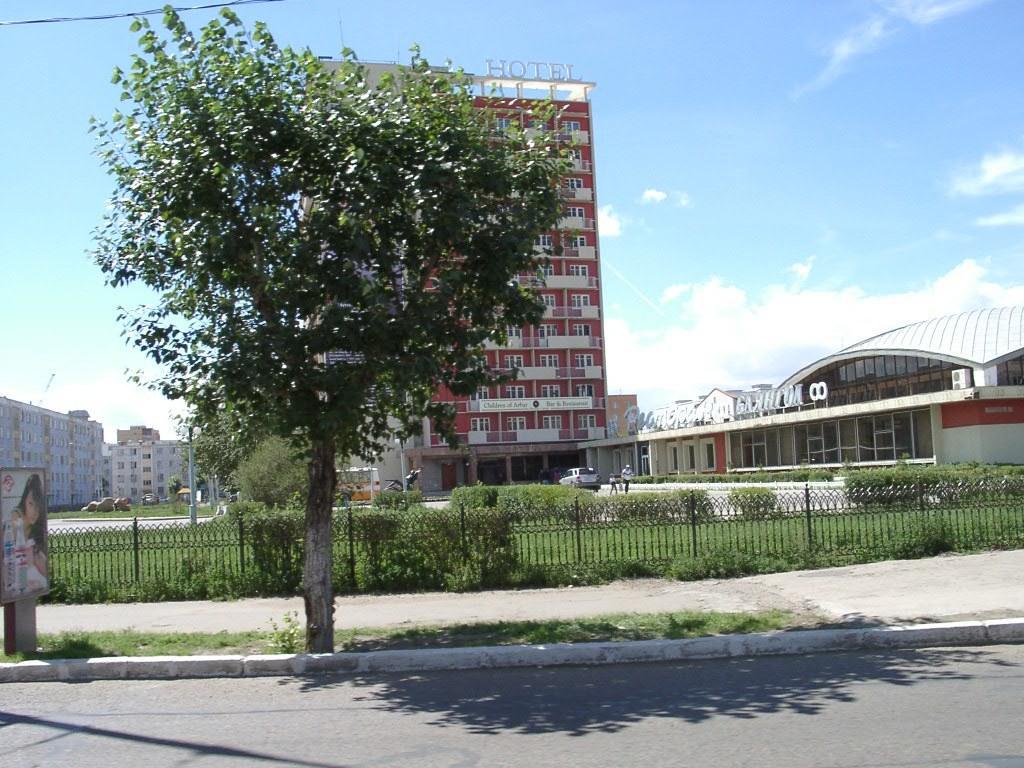Could you give a brief overview of what you see in this image? In this image I can see a board on the left. There is a tree at the front. There is a fence and grass behind it. There are people, vehicles and buildings at the back. There is sky at the top. 